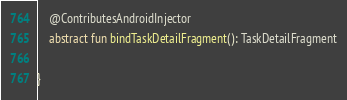Convert code to text. <code><loc_0><loc_0><loc_500><loc_500><_Kotlin_>    @ContributesAndroidInjector
    abstract fun bindTaskDetailFragment(): TaskDetailFragment

}</code> 